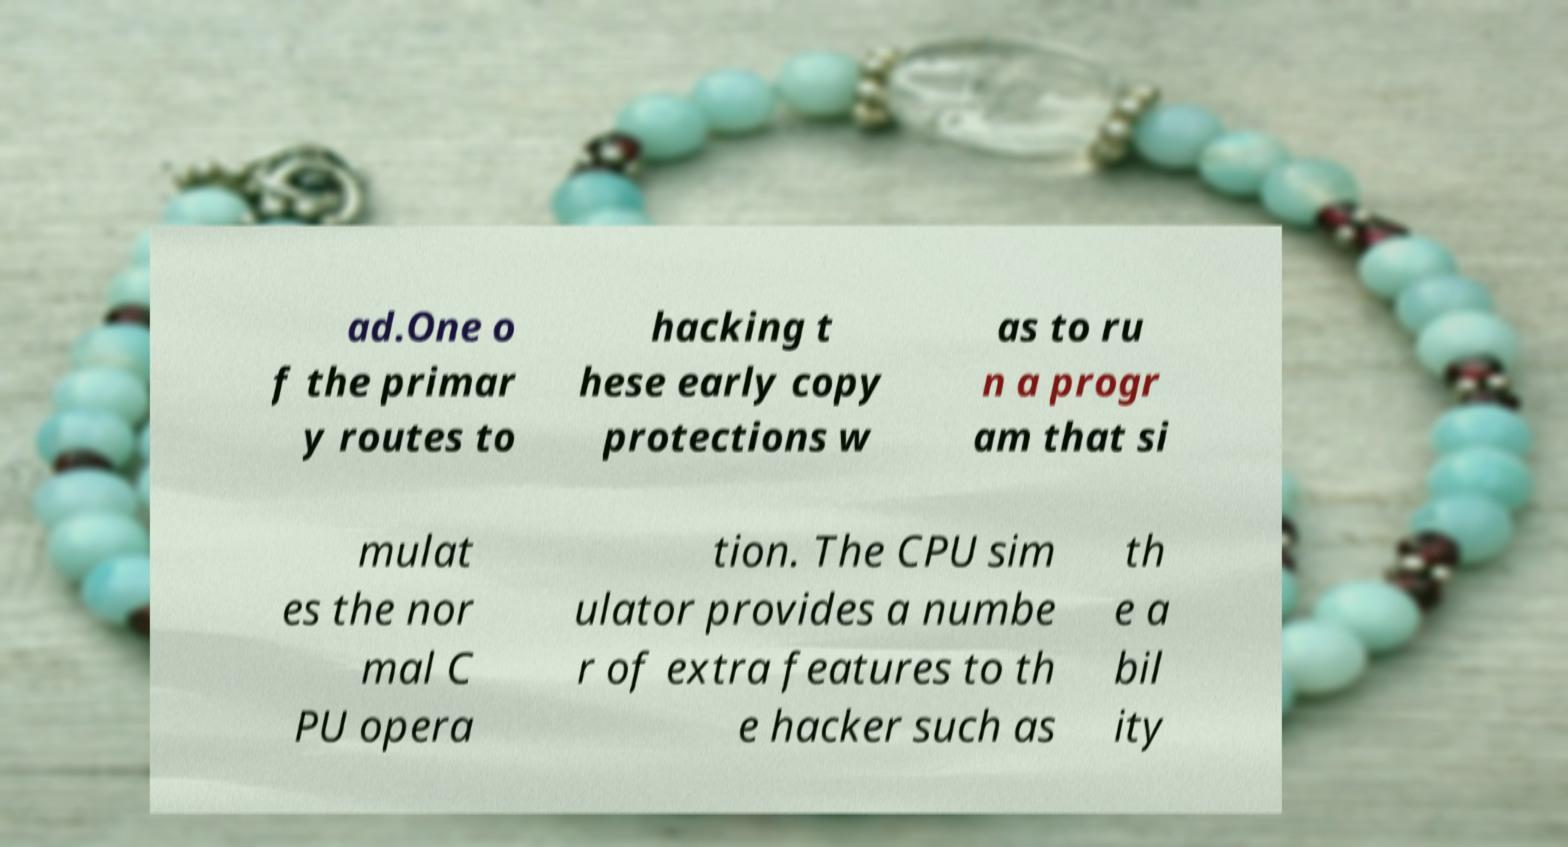There's text embedded in this image that I need extracted. Can you transcribe it verbatim? ad.One o f the primar y routes to hacking t hese early copy protections w as to ru n a progr am that si mulat es the nor mal C PU opera tion. The CPU sim ulator provides a numbe r of extra features to th e hacker such as th e a bil ity 